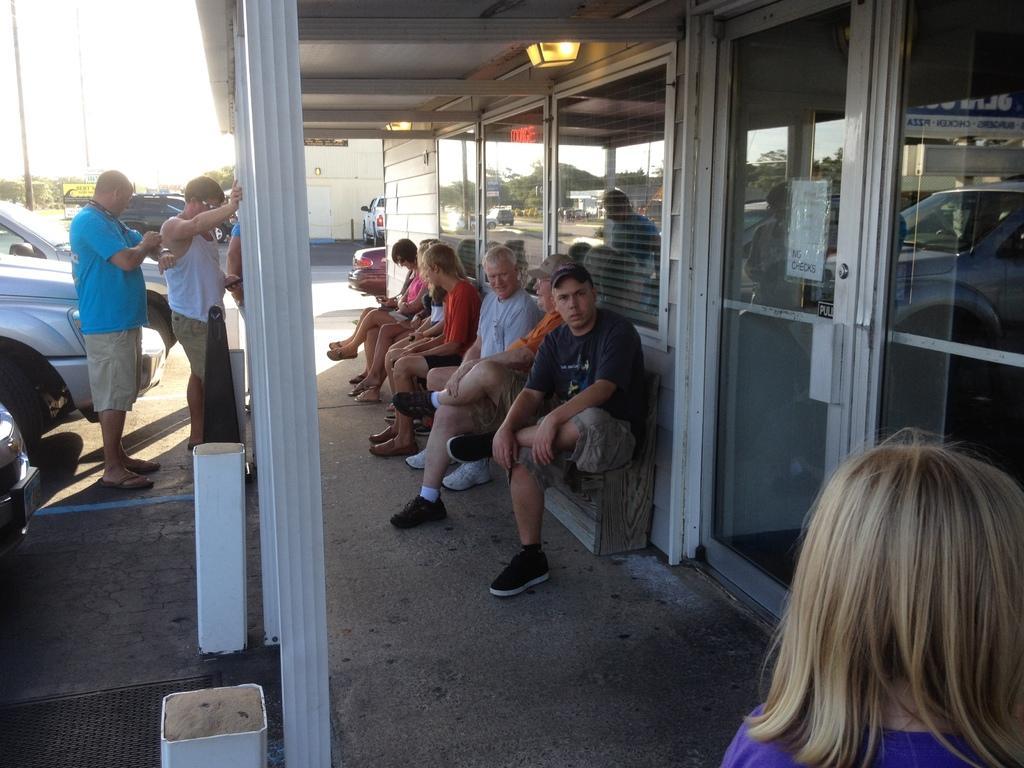Can you describe this image briefly? This is an outside view. Here I can see a building. In front of this few people are sitting on the bench. In the bottom right, I can see a person's head. On the left side, I can see few cars on the road and two men are standing. In the background I can see poles and trees. At the top I can see the sky. 